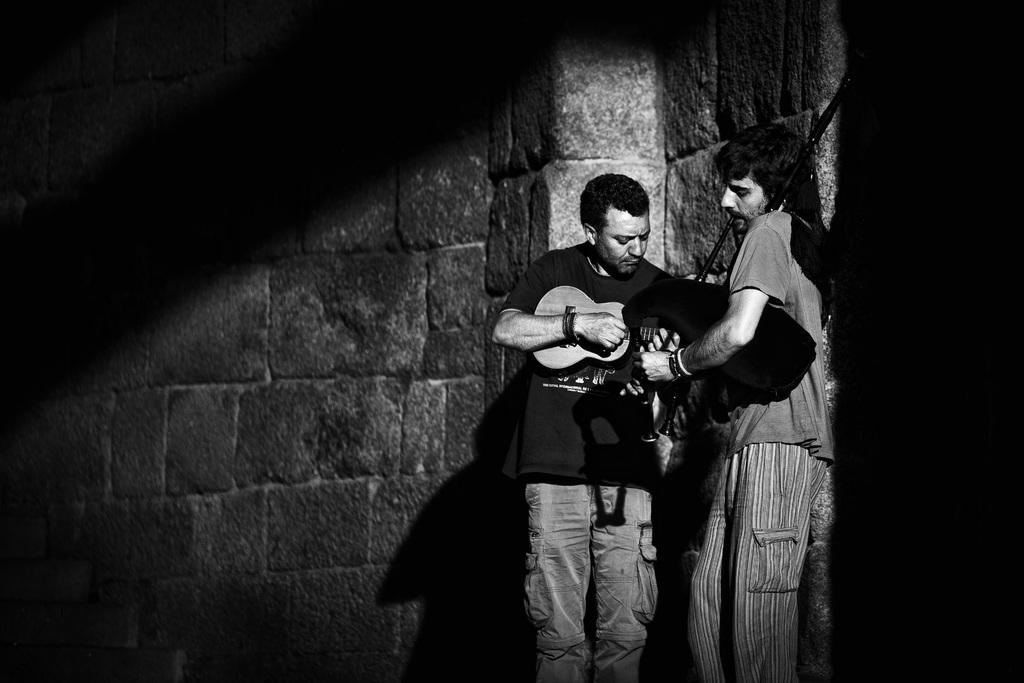How many people are in the image? There are two persons standing in the image. What is the person on the left holding? The person on the left is holding a musical instrument. What is the color scheme of the image? The image is in black and white. What type of news can be seen on the wall behind the persons in the image? There is no news or wall visible in the image; it only features two persons standing. How many spiders are crawling on the person on the right in the image? There are no spiders present in the image. 